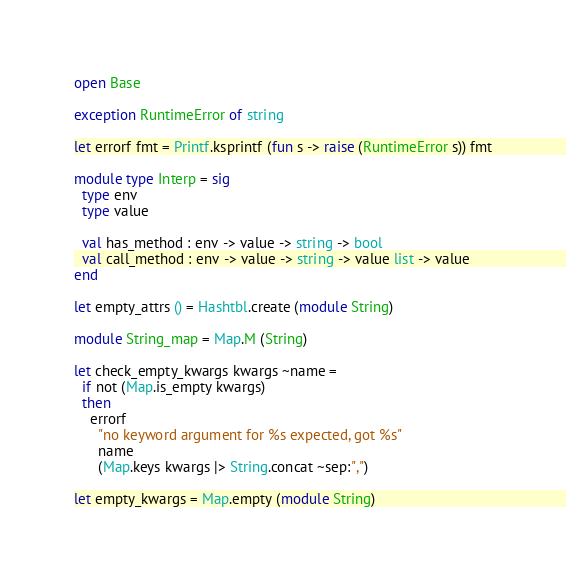Convert code to text. <code><loc_0><loc_0><loc_500><loc_500><_OCaml_>open Base

exception RuntimeError of string

let errorf fmt = Printf.ksprintf (fun s -> raise (RuntimeError s)) fmt

module type Interp = sig
  type env
  type value

  val has_method : env -> value -> string -> bool
  val call_method : env -> value -> string -> value list -> value
end

let empty_attrs () = Hashtbl.create (module String)

module String_map = Map.M (String)

let check_empty_kwargs kwargs ~name =
  if not (Map.is_empty kwargs)
  then
    errorf
      "no keyword argument for %s expected, got %s"
      name
      (Map.keys kwargs |> String.concat ~sep:",")

let empty_kwargs = Map.empty (module String)
</code> 